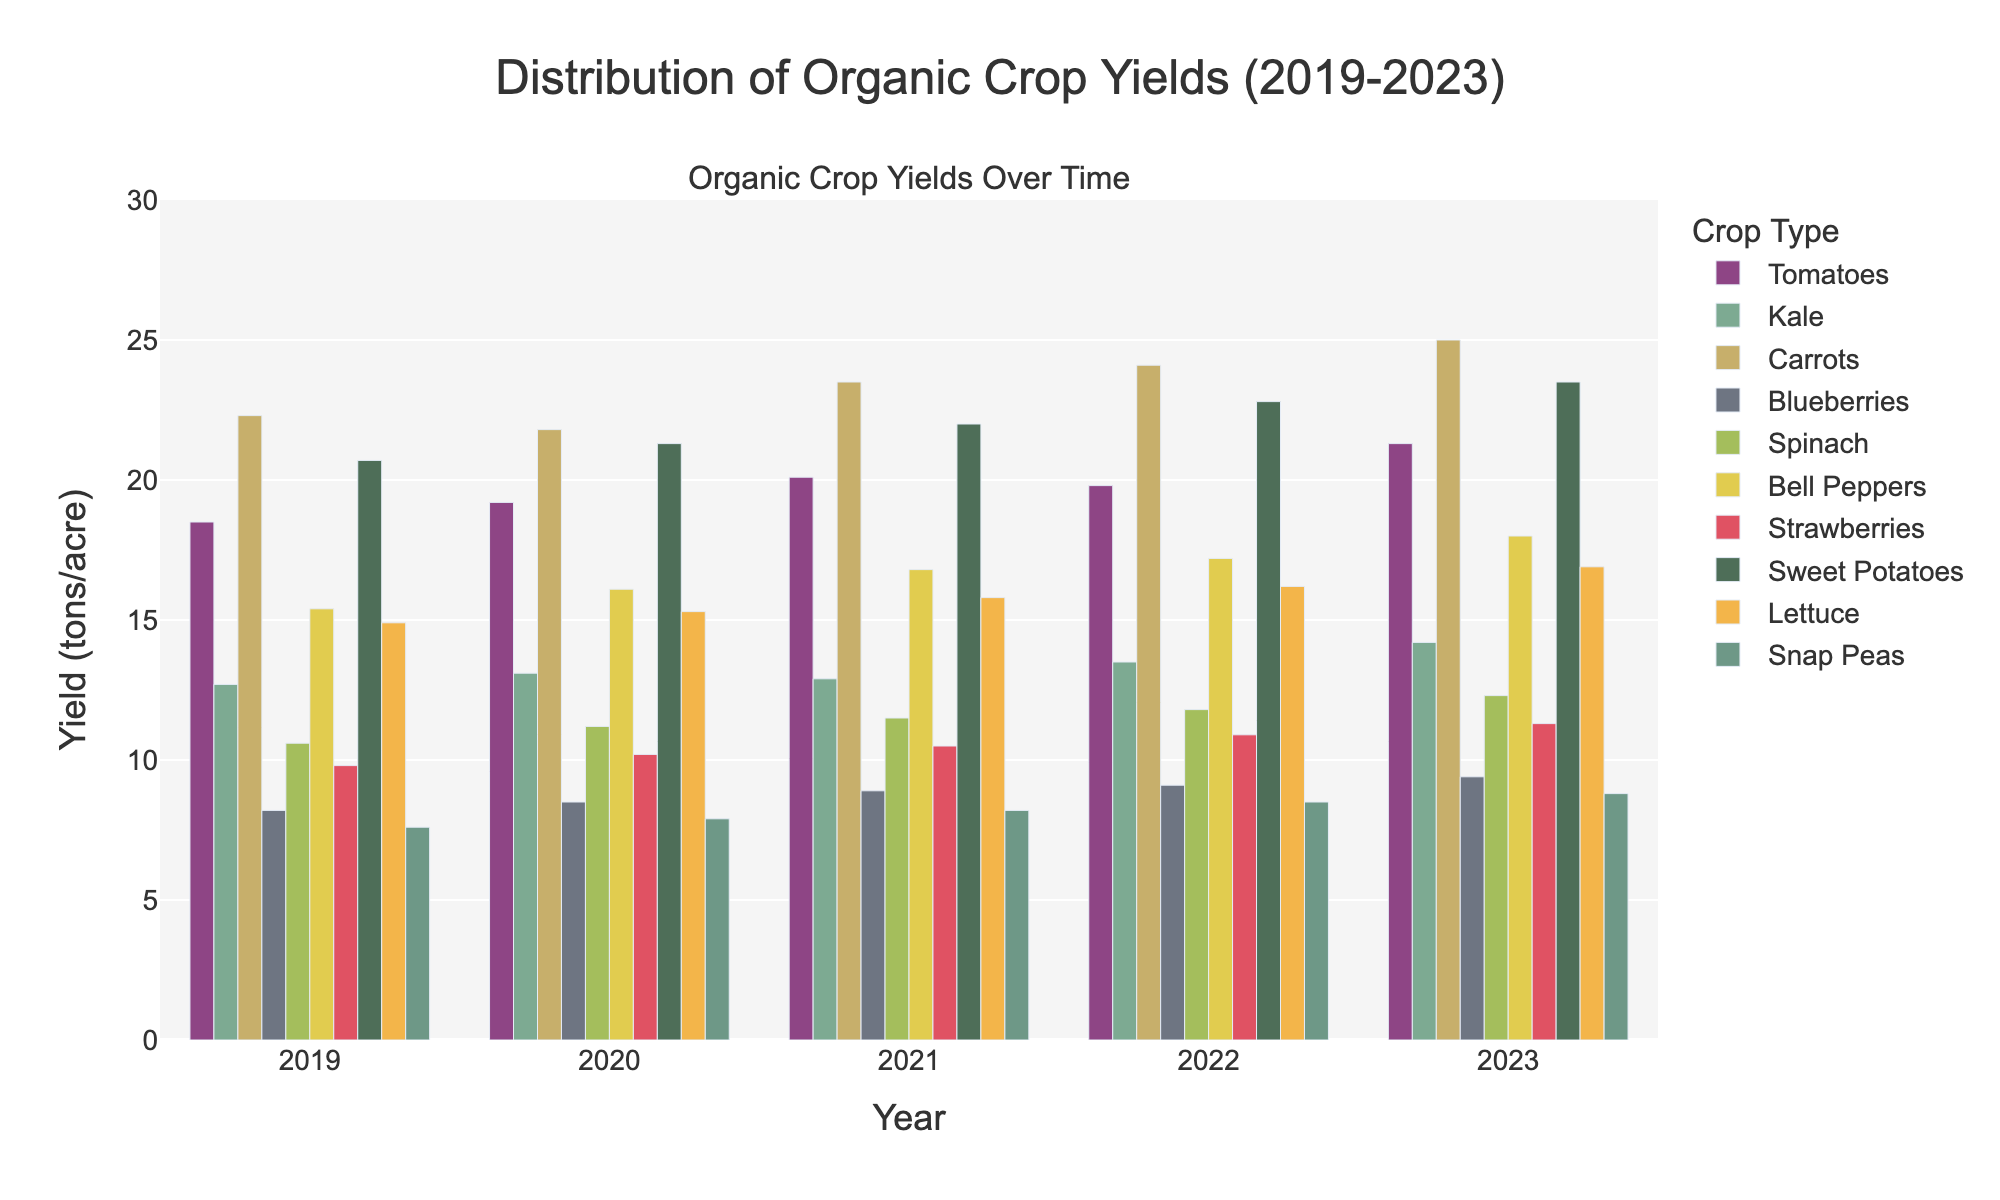Which crop type had the highest yield in 2023? Compare the heights of the bars for each crop in 2023. Carrots have the highest bar.
Answer: Carrots Which crop type shows the most consistent yield over the five years? Identify the crop with bars of similar height for each year. Snap Peas have bars that increase gradually but consistently.
Answer: Snap Peas How much did the yield of Bell Peppers increase from 2019 to 2023? Subtract the yield in 2019 from the yield in 2023 (18.0 - 15.4).
Answer: 2.6 tons/acre Compare the yields of Tomatoes and Blueberries in 2022. Which one was higher? Look at the bar heights for Tomatoes and Blueberries in 2022; the bar for Tomatoes is significantly higher.
Answer: Tomatoes What is the average yield of Strawberries from 2019 to 2023? Add the yields for Strawberries from 2019 to 2023 and divide by 5 ((9.8 + 10.2 + 10.5 + 10.9 + 11.3) / 5).
Answer: 10.54 tons/acre Which crop type had the lowest yield in 2019? Compare the bars for each crop in 2019. Snap Peas had the lowest yield.
Answer: Snap Peas What was the difference in yield between Lettuce and Kale in 2023? Subtract the yield of Kale from the yield of Lettuce in 2023 (16.9 - 14.2).
Answer: 2.7 tons/acre Which year showed the highest overall yield increase for Sweet Potatoes? Look at the difference in heights of the bars for each consecutive year; 2020 (21.3) - 2019 (20.7) is the highest difference.
Answer: 2020 Did the yield of Spinach steadily increase from 2019 to 2023? Observe the heights of Spinach’s bars from 2019 to 2023; each year's bar is higher than the previous year's.
Answer: Yes Compare the yields of Carrots and Kale in 2021. Which one had a higher yield and by how much? Compare the bar heights for Carrots and Kale in 2021 and subtract Kale's yield from Carrots' yield (23.5 - 12.9).
Answer: Carrots, 10.6 tons/acre 